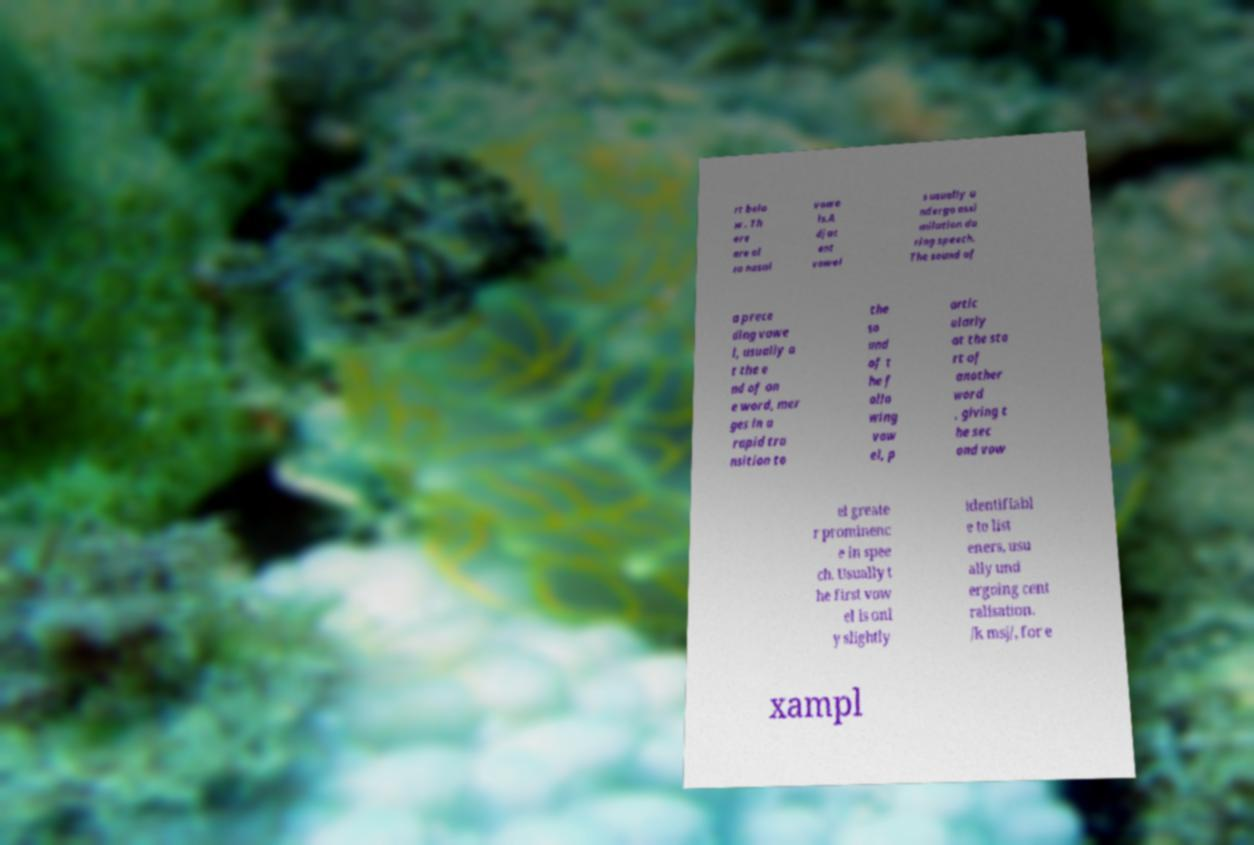Please read and relay the text visible in this image. What does it say? rt belo w . Th ere are al so nasal vowe ls.A djac ent vowel s usually u ndergo assi milation du ring speech. The sound of a prece ding vowe l, usually a t the e nd of on e word, mer ges in a rapid tra nsition to the so und of t he f ollo wing vow el, p artic ularly at the sta rt of another word , giving t he sec ond vow el greate r prominenc e in spee ch. Usually t he first vow el is onl y slightly identifiabl e to list eners, usu ally und ergoing cent ralisation. /k msj/, for e xampl 